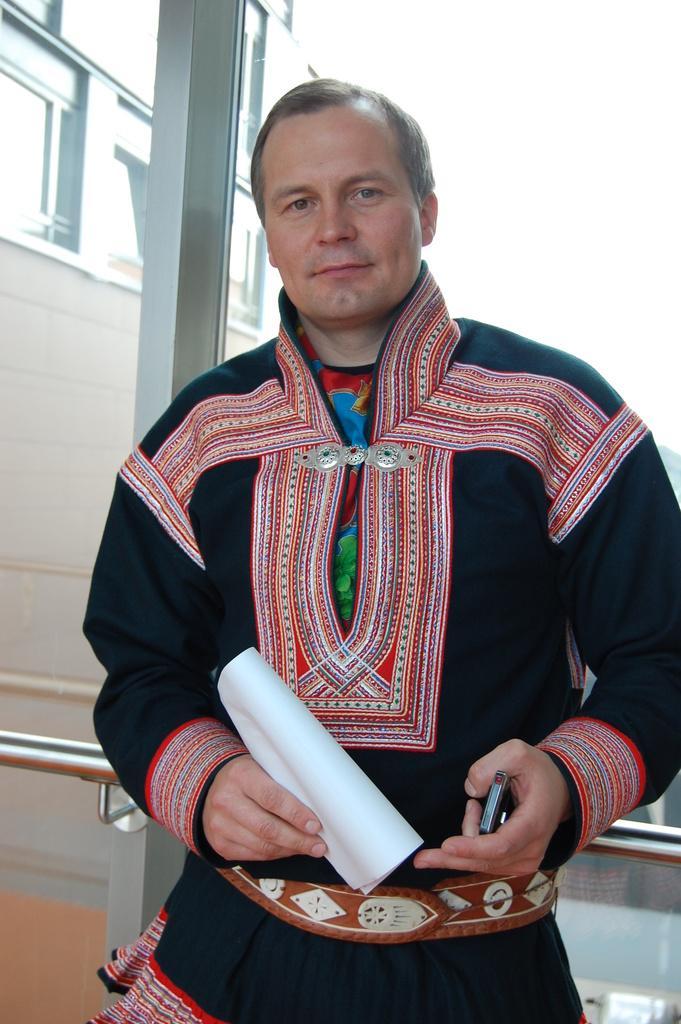Could you give a brief overview of what you see in this image? In this image I can see a person wearing black and red color dress is standing and holding a paper and an object in his hand. In the background I can see a building and the sky. I can see a metal rod behind him. 